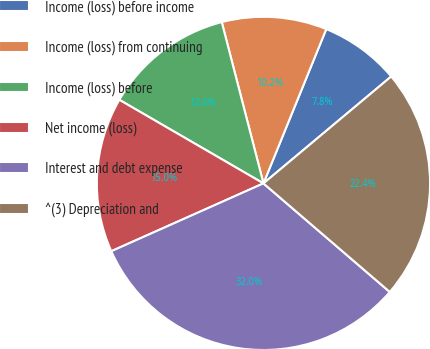Convert chart to OTSL. <chart><loc_0><loc_0><loc_500><loc_500><pie_chart><fcel>Income (loss) before income<fcel>Income (loss) from continuing<fcel>Income (loss) before<fcel>Net income (loss)<fcel>Interest and debt expense<fcel>^(3) Depreciation and<nl><fcel>7.76%<fcel>10.18%<fcel>12.61%<fcel>15.04%<fcel>32.03%<fcel>22.39%<nl></chart> 